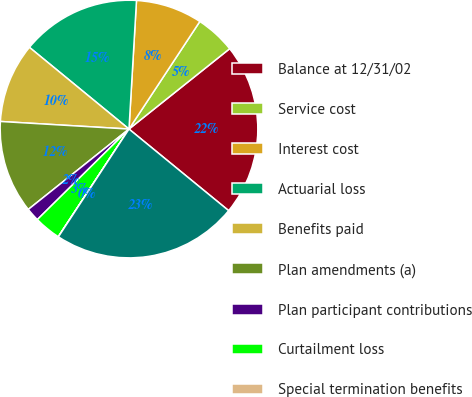<chart> <loc_0><loc_0><loc_500><loc_500><pie_chart><fcel>Balance at 12/31/02<fcel>Service cost<fcel>Interest cost<fcel>Actuarial loss<fcel>Benefits paid<fcel>Plan amendments (a)<fcel>Plan participant contributions<fcel>Curtailment loss<fcel>Special termination benefits<fcel>Balance at 12/31/03<nl><fcel>21.64%<fcel>5.01%<fcel>8.34%<fcel>14.99%<fcel>10.0%<fcel>11.66%<fcel>1.68%<fcel>3.35%<fcel>0.02%<fcel>23.31%<nl></chart> 